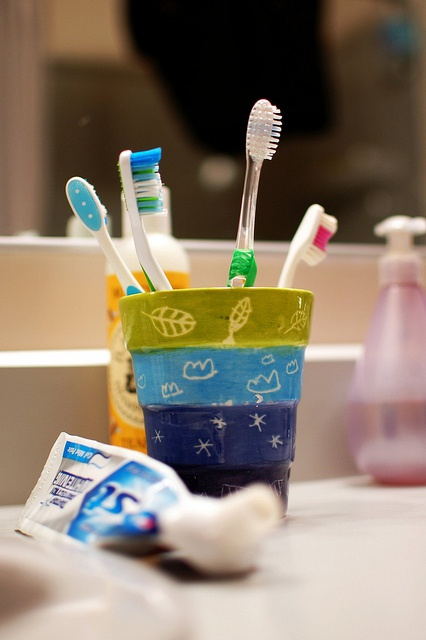Describe the objects in this image and their specific colors. I can see cup in brown, navy, olive, and teal tones, sink in brown, lightgray, gray, and tan tones, bottle in brown, pink, darkgray, gray, and lightgray tones, bottle in brown, ivory, tan, and orange tones, and toothbrush in brown, tan, ivory, darkgray, and black tones in this image. 